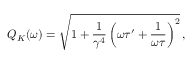Convert formula to latex. <formula><loc_0><loc_0><loc_500><loc_500>Q _ { K } ( \omega ) = \sqrt { 1 + \frac { 1 } { \gamma ^ { 4 } } \left ( \omega \tau ^ { \prime } + \frac { 1 } { \omega \tau } \right ) ^ { 2 } } \, ,</formula> 